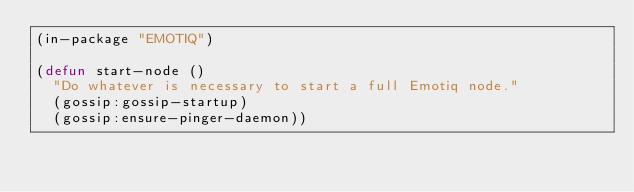Convert code to text. <code><loc_0><loc_0><loc_500><loc_500><_Lisp_>(in-package "EMOTIQ")

(defun start-node ()
  "Do whatever is necessary to start a full Emotiq node."
  (gossip:gossip-startup)
  (gossip:ensure-pinger-daemon))


</code> 